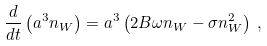Convert formula to latex. <formula><loc_0><loc_0><loc_500><loc_500>\frac { d } { d t } \left ( a ^ { 3 } n _ { W } \right ) = a ^ { 3 } \left ( 2 B \omega n _ { W } - \sigma n _ { W } ^ { 2 } \right ) \, ,</formula> 